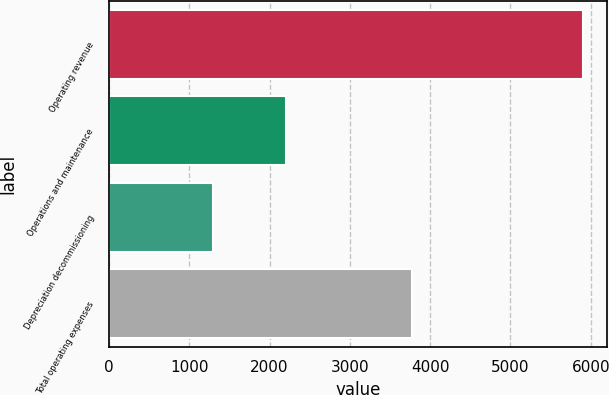<chart> <loc_0><loc_0><loc_500><loc_500><bar_chart><fcel>Operating revenue<fcel>Operations and maintenance<fcel>Depreciation decommissioning<fcel>Total operating expenses<nl><fcel>5902<fcel>2208<fcel>1294<fcel>3779<nl></chart> 